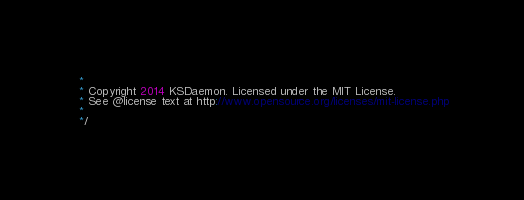Convert code to text. <code><loc_0><loc_0><loc_500><loc_500><_JavaScript_> *
 * Copyright 2014 KSDaemon. Licensed under the MIT License.
 * See @license text at http://www.opensource.org/licenses/mit-license.php
 *
 */</code> 